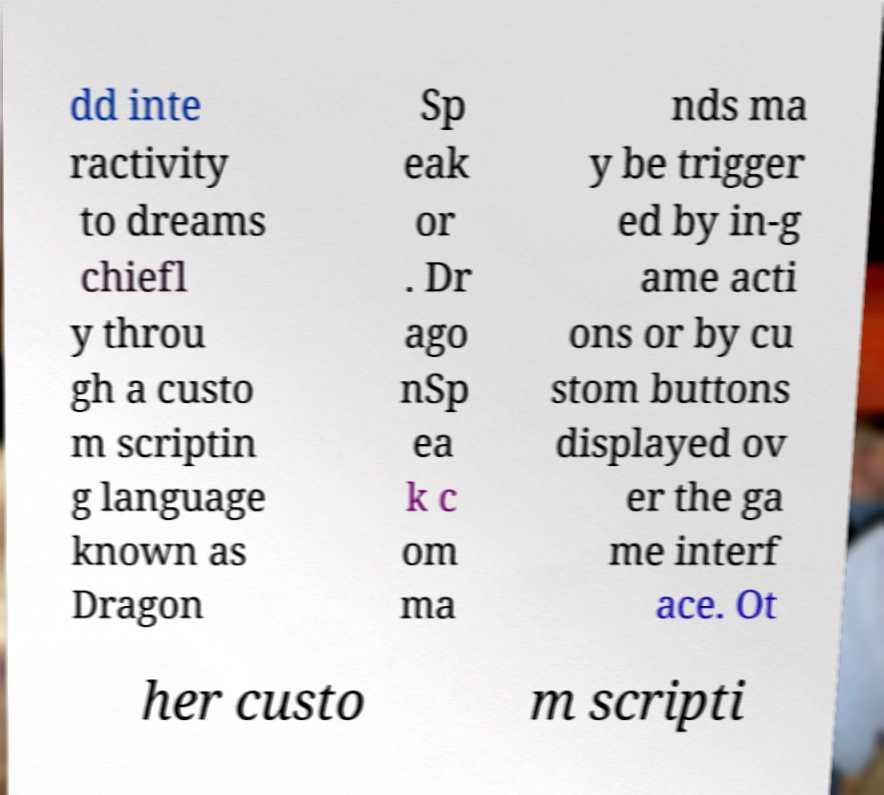Could you extract and type out the text from this image? dd inte ractivity to dreams chiefl y throu gh a custo m scriptin g language known as Dragon Sp eak or . Dr ago nSp ea k c om ma nds ma y be trigger ed by in-g ame acti ons or by cu stom buttons displayed ov er the ga me interf ace. Ot her custo m scripti 